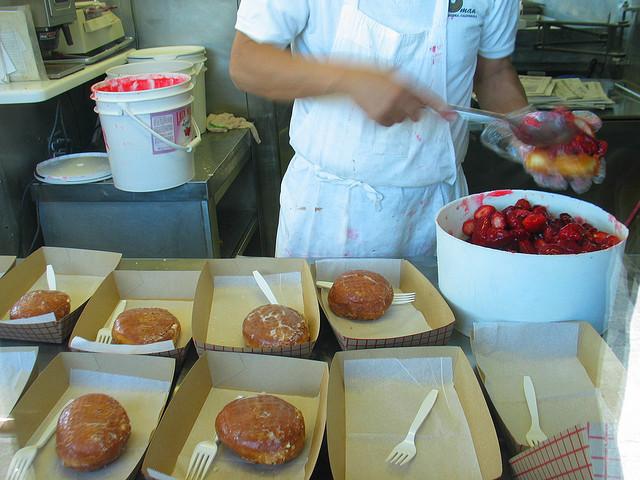Is this a display?
Quick response, please. No. Where is red jelly?
Quick response, please. Bucket. What is this guy displaying?
Concise answer only. Donuts. 